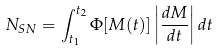Convert formula to latex. <formula><loc_0><loc_0><loc_500><loc_500>N _ { S N } = \int _ { t _ { 1 } } ^ { t _ { 2 } } \Phi [ M ( t ) ] \left | \frac { d M } { d t } \right | d t</formula> 